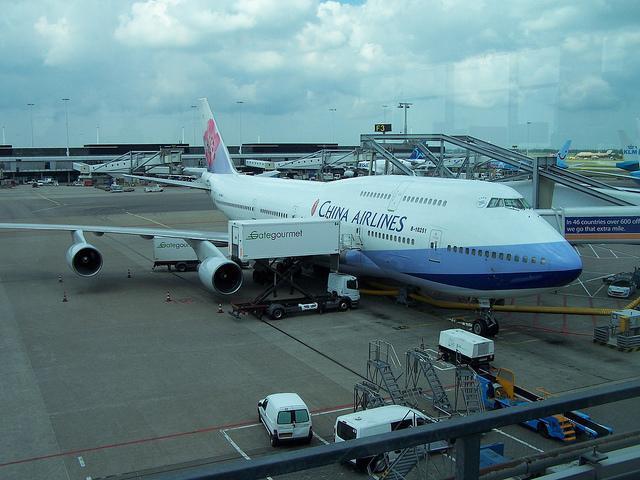How many cars are there?
Give a very brief answer. 2. 